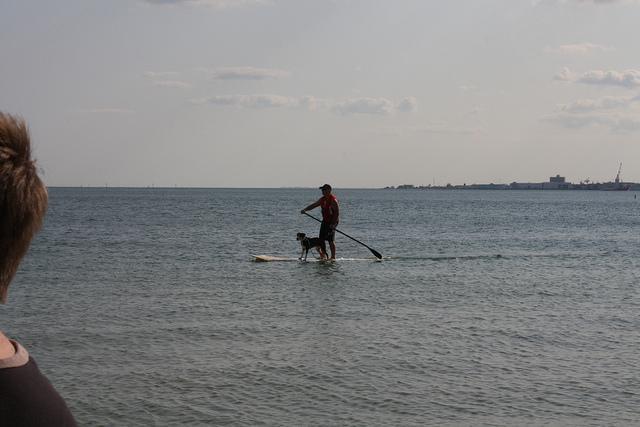How many bowls in the image contain broccoli?
Give a very brief answer. 0. 